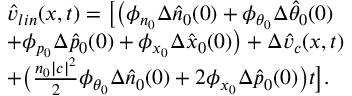Convert formula to latex. <formula><loc_0><loc_0><loc_500><loc_500>\begin{array} { r l } & { \hat { v } _ { l i n } ( x , t ) = \left [ \left ( \phi _ { n _ { 0 } } \Delta \hat { n } _ { 0 } ( 0 ) + \phi _ { \theta _ { 0 } } \Delta \hat { \theta } _ { 0 } ( 0 ) } \\ & { + \phi _ { p _ { 0 } } \Delta \hat { p } _ { 0 } ( 0 ) + \phi _ { x _ { 0 } } \Delta \hat { x } _ { 0 } ( 0 ) \right ) + \Delta \hat { v } _ { c } ( x , t ) } \\ & { + \left ( \frac { n _ { 0 } | c | ^ { 2 } } { 2 } \phi _ { \theta _ { 0 } } \Delta \hat { n } _ { 0 } ( 0 ) + 2 \phi _ { x _ { 0 } } \Delta \hat { p } _ { 0 } ( 0 ) \right ) t \right ] . } \end{array}</formula> 